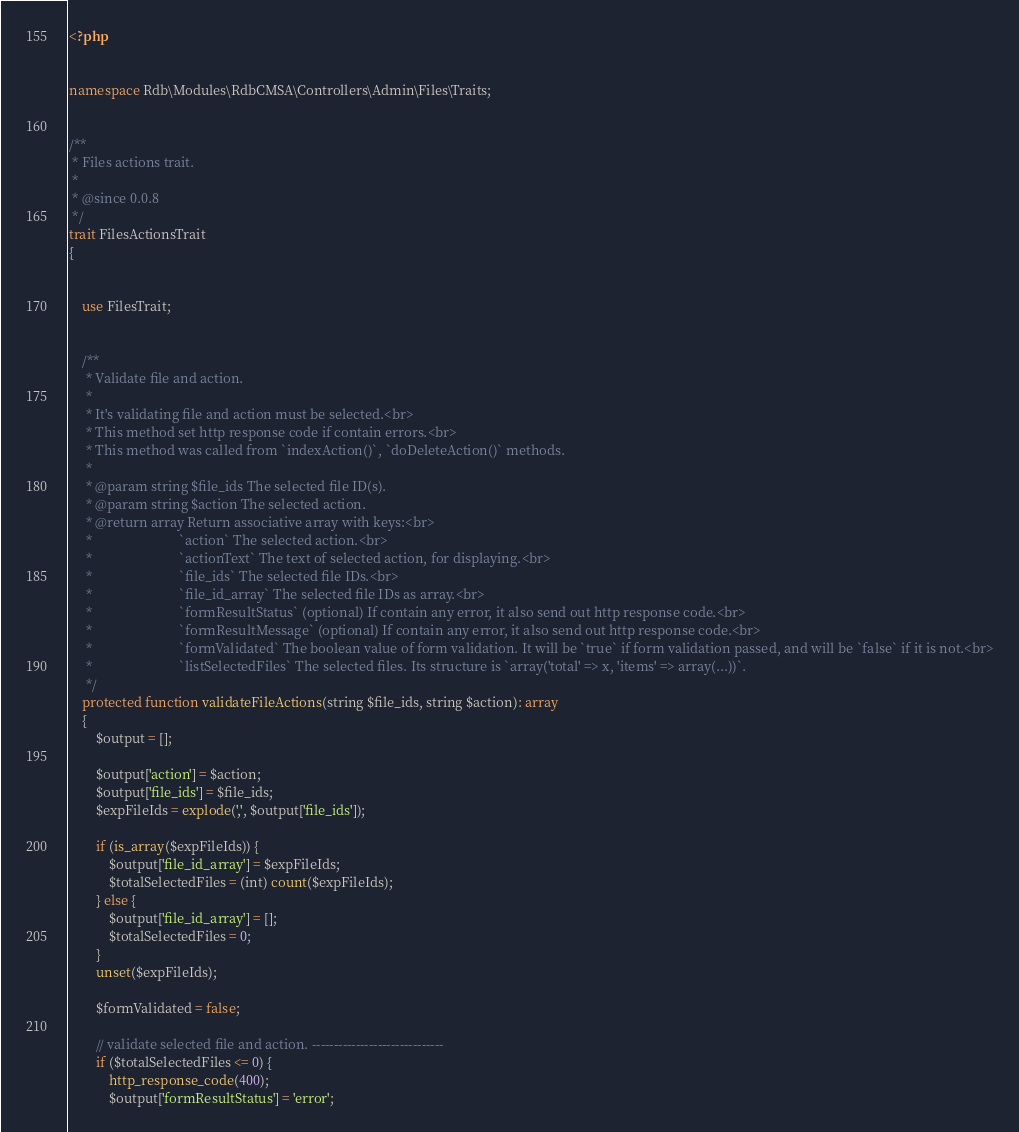<code> <loc_0><loc_0><loc_500><loc_500><_PHP_><?php


namespace Rdb\Modules\RdbCMSA\Controllers\Admin\Files\Traits;


/**
 * Files actions trait.
 * 
 * @since 0.0.8
 */
trait FilesActionsTrait
{


    use FilesTrait;


    /**
     * Validate file and action.
     * 
     * It's validating file and action must be selected.<br>
     * This method set http response code if contain errors.<br>
     * This method was called from `indexAction()`, `doDeleteAction()` methods.
     * 
     * @param string $file_ids The selected file ID(s).
     * @param string $action The selected action.
     * @return array Return associative array with keys:<br>
     *                          `action` The selected action.<br>
     *                          `actionText` The text of selected action, for displaying.<br>
     *                          `file_ids` The selected file IDs.<br>
     *                          `file_id_array` The selected file IDs as array.<br>
     *                          `formResultStatus` (optional) If contain any error, it also send out http response code.<br>
     *                          `formResultMessage` (optional) If contain any error, it also send out http response code.<br>
     *                          `formValidated` The boolean value of form validation. It will be `true` if form validation passed, and will be `false` if it is not.<br>
     *                          `listSelectedFiles` The selected files. Its structure is `array('total' => x, 'items' => array(...))`.
     */
    protected function validateFileActions(string $file_ids, string $action): array
    {
        $output = [];

        $output['action'] = $action;
        $output['file_ids'] = $file_ids;
        $expFileIds = explode(',', $output['file_ids']);

        if (is_array($expFileIds)) {
            $output['file_id_array'] = $expFileIds;
            $totalSelectedFiles = (int) count($expFileIds);
        } else {
            $output['file_id_array'] = [];
            $totalSelectedFiles = 0;
        }
        unset($expFileIds);

        $formValidated = false;

        // validate selected file and action. ------------------------------
        if ($totalSelectedFiles <= 0) {
            http_response_code(400);
            $output['formResultStatus'] = 'error';</code> 